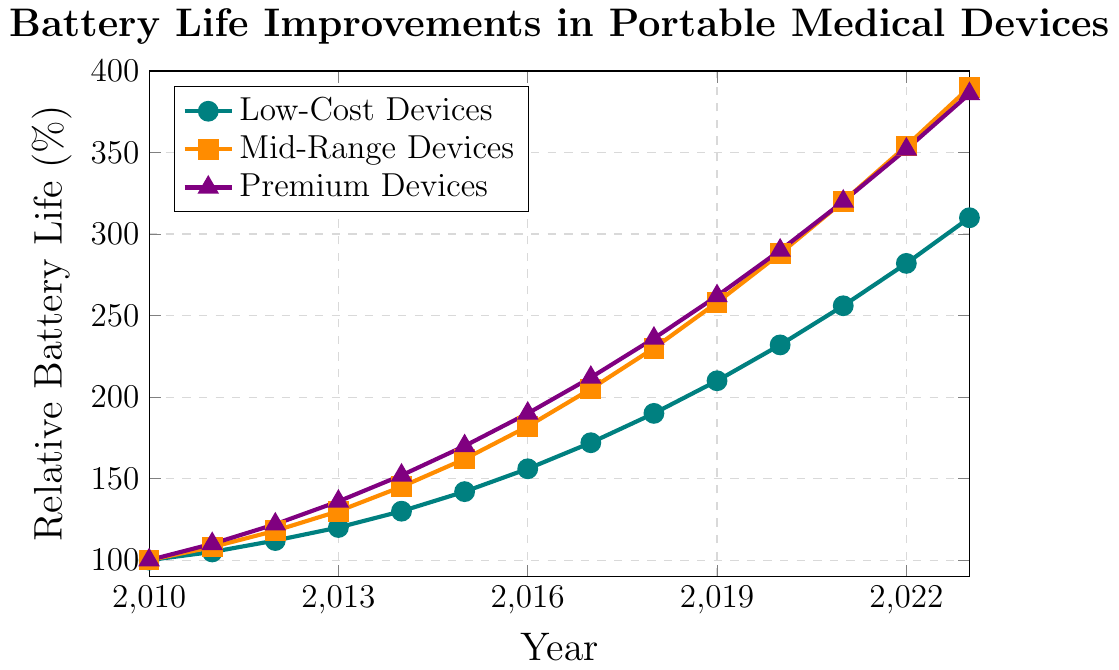Which device type showed the most improvement in battery life from 2010 to 2023? To determine the device type with the most improvement, subtract the initial battery life in 2010 from the final battery life in 2023 for each device type: Low-Cost (310 - 100), Mid-Range (390 - 100), and Premium (386 - 100). Mid-Range Devices improvement is 290%, followed by Premium Devices at 286%, and Low-Cost Devices at 210%. Therefore, the Mid-Range Devices showed the most improvement.
Answer: Mid-Range Devices In which year did Low-Cost Devices surpass 200% battery life improvement? Low-Cost Devices surpassed 200% battery life improvement in the year where the battery life value was more than 200. According to the chart, Low-Cost Devices reached 210% in 2019.
Answer: 2019 By how many percentage points did Premium Devices' battery life increase from 2015 to 2020? Subtract the battery life percentage of Premium Devices in 2015 from the value in 2020: 290 - 170. The increase was 120 percentage points.
Answer: 120 percentage points Which device type had the highest battery life in 2021? By checking the values in 2021, we see that Low-Cost Devices are at 256%, Mid-Range Devices at 320%, and Premium Devices also at 320%. Both Mid-Range and Premium Devices had the highest battery life, tied at 320%.
Answer: Mid-Range and Premium Devices Compare the growth rate of battery life for Mid-Range and Premium Devices between 2018 and 2023. Which grew faster? Calculate the percentage increase for each type from 2018 to 2023. 
Mid-Range increase: ((390 - 230) / 230) * 100 = 69.6%.
Premium increase: ((386 - 236) / 236) * 100 = 63.6%. 
Mid-Range Devices grew faster with a 69.6% increase compared to Premium's 63.6%.
Answer: Mid-Range Devices What is the difference in battery life percentage between Low-Cost and Premium Devices in 2022? Subtract the battery life of Low-Cost Devices from Premium Devices in 2022: 352 - 282. The difference is 70 percentage points.
Answer: 70 percentage points At what year did Mid-Range Devices first exceed a battery life of 300%? Mid-Range Devices exceeded 300% battery life in the year where the value is more than 300. According to the chart, this occurs in 2021.
Answer: 2021 What is the average battery life of Low-Cost Devices from 2010 to 2023? Sum the battery life values of Low-Cost Devices from 2010 to 2023 and divide by the number of years (14). (100 + 105 + 112 + 120 + 130 + 142 + 156 + 172 + 190 + 210 + 232 + 256 + 282 + 310) / 14 = 191.43%.
Answer: 191.43% How much more did Mid-Range Devices' battery life improve compared to Low-Cost Devices from 2010 to 2023? Find the difference between the total improvements of both device types. Mid-Range: 390 - 100 = 290%. Low-Cost: 310 - 100 = 210%. Therefore, 290 - 210 = 80%. Mid-Range Devices improved 80% more than Low-Cost Devices.
Answer: 80% In which range did all devices' battery life surpass 200% and in what year did it happen for each group? Identify the year where each device first exceeded 200%. Low-Cost Devices: 2019, Mid-Range Devices: 2017, Premium Devices: 2017.
Answer: Low-Cost: 2019, Mid-Range: 2017, Premium: 2017 